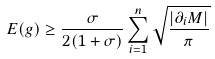<formula> <loc_0><loc_0><loc_500><loc_500>E ( g ) \geq \frac { \sigma } { 2 ( 1 + \sigma ) } \sum _ { i = 1 } ^ { n } \sqrt { \frac { | \partial _ { i } M | } { \pi } }</formula> 